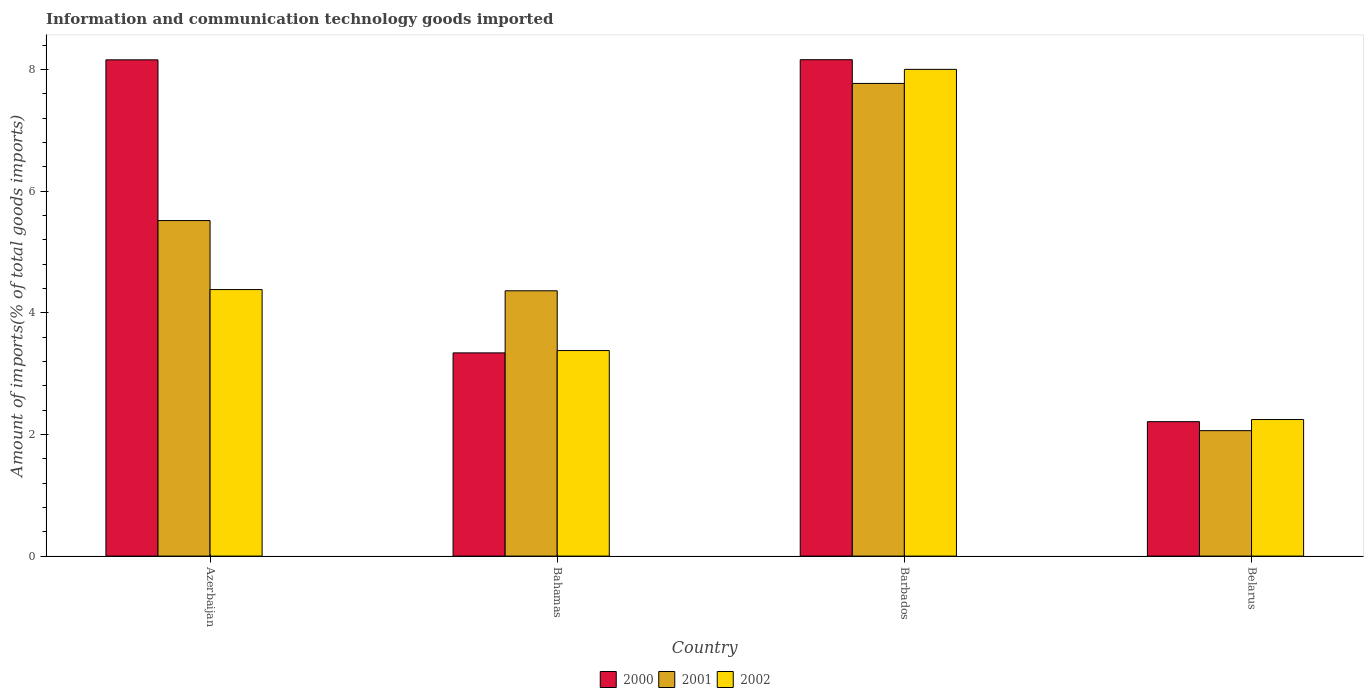Are the number of bars per tick equal to the number of legend labels?
Give a very brief answer. Yes. Are the number of bars on each tick of the X-axis equal?
Your answer should be compact. Yes. How many bars are there on the 3rd tick from the right?
Your answer should be compact. 3. What is the label of the 3rd group of bars from the left?
Ensure brevity in your answer.  Barbados. What is the amount of goods imported in 2000 in Bahamas?
Your answer should be very brief. 3.34. Across all countries, what is the maximum amount of goods imported in 2001?
Your response must be concise. 7.77. Across all countries, what is the minimum amount of goods imported in 2001?
Give a very brief answer. 2.06. In which country was the amount of goods imported in 2002 maximum?
Make the answer very short. Barbados. In which country was the amount of goods imported in 2001 minimum?
Offer a terse response. Belarus. What is the total amount of goods imported in 2000 in the graph?
Ensure brevity in your answer.  21.88. What is the difference between the amount of goods imported in 2002 in Bahamas and that in Barbados?
Offer a very short reply. -4.62. What is the difference between the amount of goods imported in 2000 in Barbados and the amount of goods imported in 2001 in Belarus?
Offer a very short reply. 6.1. What is the average amount of goods imported in 2000 per country?
Offer a terse response. 5.47. What is the difference between the amount of goods imported of/in 2001 and amount of goods imported of/in 2000 in Barbados?
Your answer should be very brief. -0.39. In how many countries, is the amount of goods imported in 2002 greater than 6.4 %?
Offer a very short reply. 1. What is the ratio of the amount of goods imported in 2002 in Azerbaijan to that in Barbados?
Offer a terse response. 0.55. Is the difference between the amount of goods imported in 2001 in Azerbaijan and Bahamas greater than the difference between the amount of goods imported in 2000 in Azerbaijan and Bahamas?
Provide a short and direct response. No. What is the difference between the highest and the second highest amount of goods imported in 2002?
Provide a short and direct response. 4.62. What is the difference between the highest and the lowest amount of goods imported in 2000?
Make the answer very short. 5.95. In how many countries, is the amount of goods imported in 2002 greater than the average amount of goods imported in 2002 taken over all countries?
Your response must be concise. 1. Is the sum of the amount of goods imported in 2002 in Azerbaijan and Bahamas greater than the maximum amount of goods imported in 2001 across all countries?
Your answer should be very brief. No. What does the 1st bar from the left in Belarus represents?
Your answer should be compact. 2000. Is it the case that in every country, the sum of the amount of goods imported in 2000 and amount of goods imported in 2001 is greater than the amount of goods imported in 2002?
Ensure brevity in your answer.  Yes. What is the difference between two consecutive major ticks on the Y-axis?
Keep it short and to the point. 2. Does the graph contain grids?
Offer a terse response. No. Where does the legend appear in the graph?
Your response must be concise. Bottom center. How many legend labels are there?
Provide a short and direct response. 3. How are the legend labels stacked?
Make the answer very short. Horizontal. What is the title of the graph?
Provide a short and direct response. Information and communication technology goods imported. Does "1997" appear as one of the legend labels in the graph?
Keep it short and to the point. No. What is the label or title of the Y-axis?
Make the answer very short. Amount of imports(% of total goods imports). What is the Amount of imports(% of total goods imports) of 2000 in Azerbaijan?
Provide a short and direct response. 8.16. What is the Amount of imports(% of total goods imports) of 2001 in Azerbaijan?
Ensure brevity in your answer.  5.52. What is the Amount of imports(% of total goods imports) in 2002 in Azerbaijan?
Ensure brevity in your answer.  4.38. What is the Amount of imports(% of total goods imports) of 2000 in Bahamas?
Your response must be concise. 3.34. What is the Amount of imports(% of total goods imports) in 2001 in Bahamas?
Give a very brief answer. 4.36. What is the Amount of imports(% of total goods imports) of 2002 in Bahamas?
Your answer should be very brief. 3.38. What is the Amount of imports(% of total goods imports) in 2000 in Barbados?
Provide a succinct answer. 8.16. What is the Amount of imports(% of total goods imports) of 2001 in Barbados?
Make the answer very short. 7.77. What is the Amount of imports(% of total goods imports) in 2002 in Barbados?
Offer a terse response. 8. What is the Amount of imports(% of total goods imports) in 2000 in Belarus?
Ensure brevity in your answer.  2.21. What is the Amount of imports(% of total goods imports) in 2001 in Belarus?
Provide a short and direct response. 2.06. What is the Amount of imports(% of total goods imports) in 2002 in Belarus?
Your answer should be very brief. 2.25. Across all countries, what is the maximum Amount of imports(% of total goods imports) in 2000?
Ensure brevity in your answer.  8.16. Across all countries, what is the maximum Amount of imports(% of total goods imports) of 2001?
Provide a short and direct response. 7.77. Across all countries, what is the maximum Amount of imports(% of total goods imports) in 2002?
Keep it short and to the point. 8. Across all countries, what is the minimum Amount of imports(% of total goods imports) of 2000?
Give a very brief answer. 2.21. Across all countries, what is the minimum Amount of imports(% of total goods imports) of 2001?
Your answer should be compact. 2.06. Across all countries, what is the minimum Amount of imports(% of total goods imports) in 2002?
Offer a very short reply. 2.25. What is the total Amount of imports(% of total goods imports) in 2000 in the graph?
Make the answer very short. 21.88. What is the total Amount of imports(% of total goods imports) in 2001 in the graph?
Offer a terse response. 19.71. What is the total Amount of imports(% of total goods imports) in 2002 in the graph?
Your response must be concise. 18.01. What is the difference between the Amount of imports(% of total goods imports) in 2000 in Azerbaijan and that in Bahamas?
Make the answer very short. 4.82. What is the difference between the Amount of imports(% of total goods imports) in 2001 in Azerbaijan and that in Bahamas?
Ensure brevity in your answer.  1.15. What is the difference between the Amount of imports(% of total goods imports) in 2002 in Azerbaijan and that in Bahamas?
Provide a short and direct response. 1. What is the difference between the Amount of imports(% of total goods imports) of 2000 in Azerbaijan and that in Barbados?
Your answer should be compact. -0. What is the difference between the Amount of imports(% of total goods imports) in 2001 in Azerbaijan and that in Barbados?
Your answer should be very brief. -2.26. What is the difference between the Amount of imports(% of total goods imports) of 2002 in Azerbaijan and that in Barbados?
Your answer should be compact. -3.62. What is the difference between the Amount of imports(% of total goods imports) in 2000 in Azerbaijan and that in Belarus?
Ensure brevity in your answer.  5.95. What is the difference between the Amount of imports(% of total goods imports) in 2001 in Azerbaijan and that in Belarus?
Provide a succinct answer. 3.45. What is the difference between the Amount of imports(% of total goods imports) of 2002 in Azerbaijan and that in Belarus?
Make the answer very short. 2.14. What is the difference between the Amount of imports(% of total goods imports) of 2000 in Bahamas and that in Barbados?
Provide a succinct answer. -4.82. What is the difference between the Amount of imports(% of total goods imports) in 2001 in Bahamas and that in Barbados?
Provide a succinct answer. -3.41. What is the difference between the Amount of imports(% of total goods imports) of 2002 in Bahamas and that in Barbados?
Offer a terse response. -4.62. What is the difference between the Amount of imports(% of total goods imports) of 2000 in Bahamas and that in Belarus?
Your answer should be very brief. 1.13. What is the difference between the Amount of imports(% of total goods imports) of 2001 in Bahamas and that in Belarus?
Provide a short and direct response. 2.3. What is the difference between the Amount of imports(% of total goods imports) of 2002 in Bahamas and that in Belarus?
Make the answer very short. 1.13. What is the difference between the Amount of imports(% of total goods imports) in 2000 in Barbados and that in Belarus?
Make the answer very short. 5.95. What is the difference between the Amount of imports(% of total goods imports) of 2001 in Barbados and that in Belarus?
Provide a succinct answer. 5.71. What is the difference between the Amount of imports(% of total goods imports) in 2002 in Barbados and that in Belarus?
Offer a very short reply. 5.76. What is the difference between the Amount of imports(% of total goods imports) of 2000 in Azerbaijan and the Amount of imports(% of total goods imports) of 2001 in Bahamas?
Offer a terse response. 3.8. What is the difference between the Amount of imports(% of total goods imports) of 2000 in Azerbaijan and the Amount of imports(% of total goods imports) of 2002 in Bahamas?
Provide a short and direct response. 4.78. What is the difference between the Amount of imports(% of total goods imports) of 2001 in Azerbaijan and the Amount of imports(% of total goods imports) of 2002 in Bahamas?
Offer a terse response. 2.14. What is the difference between the Amount of imports(% of total goods imports) of 2000 in Azerbaijan and the Amount of imports(% of total goods imports) of 2001 in Barbados?
Ensure brevity in your answer.  0.39. What is the difference between the Amount of imports(% of total goods imports) of 2000 in Azerbaijan and the Amount of imports(% of total goods imports) of 2002 in Barbados?
Offer a very short reply. 0.16. What is the difference between the Amount of imports(% of total goods imports) in 2001 in Azerbaijan and the Amount of imports(% of total goods imports) in 2002 in Barbados?
Your answer should be compact. -2.49. What is the difference between the Amount of imports(% of total goods imports) of 2000 in Azerbaijan and the Amount of imports(% of total goods imports) of 2001 in Belarus?
Offer a very short reply. 6.1. What is the difference between the Amount of imports(% of total goods imports) of 2000 in Azerbaijan and the Amount of imports(% of total goods imports) of 2002 in Belarus?
Offer a terse response. 5.92. What is the difference between the Amount of imports(% of total goods imports) of 2001 in Azerbaijan and the Amount of imports(% of total goods imports) of 2002 in Belarus?
Your answer should be compact. 3.27. What is the difference between the Amount of imports(% of total goods imports) of 2000 in Bahamas and the Amount of imports(% of total goods imports) of 2001 in Barbados?
Ensure brevity in your answer.  -4.43. What is the difference between the Amount of imports(% of total goods imports) in 2000 in Bahamas and the Amount of imports(% of total goods imports) in 2002 in Barbados?
Ensure brevity in your answer.  -4.66. What is the difference between the Amount of imports(% of total goods imports) in 2001 in Bahamas and the Amount of imports(% of total goods imports) in 2002 in Barbados?
Your answer should be very brief. -3.64. What is the difference between the Amount of imports(% of total goods imports) in 2000 in Bahamas and the Amount of imports(% of total goods imports) in 2001 in Belarus?
Provide a short and direct response. 1.28. What is the difference between the Amount of imports(% of total goods imports) in 2000 in Bahamas and the Amount of imports(% of total goods imports) in 2002 in Belarus?
Keep it short and to the point. 1.1. What is the difference between the Amount of imports(% of total goods imports) of 2001 in Bahamas and the Amount of imports(% of total goods imports) of 2002 in Belarus?
Your answer should be very brief. 2.12. What is the difference between the Amount of imports(% of total goods imports) of 2000 in Barbados and the Amount of imports(% of total goods imports) of 2001 in Belarus?
Your answer should be compact. 6.1. What is the difference between the Amount of imports(% of total goods imports) in 2000 in Barbados and the Amount of imports(% of total goods imports) in 2002 in Belarus?
Provide a short and direct response. 5.92. What is the difference between the Amount of imports(% of total goods imports) in 2001 in Barbados and the Amount of imports(% of total goods imports) in 2002 in Belarus?
Provide a short and direct response. 5.53. What is the average Amount of imports(% of total goods imports) in 2000 per country?
Make the answer very short. 5.47. What is the average Amount of imports(% of total goods imports) of 2001 per country?
Keep it short and to the point. 4.93. What is the average Amount of imports(% of total goods imports) in 2002 per country?
Offer a very short reply. 4.5. What is the difference between the Amount of imports(% of total goods imports) in 2000 and Amount of imports(% of total goods imports) in 2001 in Azerbaijan?
Your response must be concise. 2.64. What is the difference between the Amount of imports(% of total goods imports) in 2000 and Amount of imports(% of total goods imports) in 2002 in Azerbaijan?
Keep it short and to the point. 3.78. What is the difference between the Amount of imports(% of total goods imports) of 2001 and Amount of imports(% of total goods imports) of 2002 in Azerbaijan?
Offer a terse response. 1.13. What is the difference between the Amount of imports(% of total goods imports) in 2000 and Amount of imports(% of total goods imports) in 2001 in Bahamas?
Your answer should be compact. -1.02. What is the difference between the Amount of imports(% of total goods imports) in 2000 and Amount of imports(% of total goods imports) in 2002 in Bahamas?
Give a very brief answer. -0.04. What is the difference between the Amount of imports(% of total goods imports) of 2001 and Amount of imports(% of total goods imports) of 2002 in Bahamas?
Offer a terse response. 0.98. What is the difference between the Amount of imports(% of total goods imports) in 2000 and Amount of imports(% of total goods imports) in 2001 in Barbados?
Your response must be concise. 0.39. What is the difference between the Amount of imports(% of total goods imports) of 2000 and Amount of imports(% of total goods imports) of 2002 in Barbados?
Your response must be concise. 0.16. What is the difference between the Amount of imports(% of total goods imports) in 2001 and Amount of imports(% of total goods imports) in 2002 in Barbados?
Provide a short and direct response. -0.23. What is the difference between the Amount of imports(% of total goods imports) in 2000 and Amount of imports(% of total goods imports) in 2001 in Belarus?
Provide a short and direct response. 0.15. What is the difference between the Amount of imports(% of total goods imports) of 2000 and Amount of imports(% of total goods imports) of 2002 in Belarus?
Your response must be concise. -0.03. What is the difference between the Amount of imports(% of total goods imports) in 2001 and Amount of imports(% of total goods imports) in 2002 in Belarus?
Ensure brevity in your answer.  -0.18. What is the ratio of the Amount of imports(% of total goods imports) in 2000 in Azerbaijan to that in Bahamas?
Your answer should be compact. 2.44. What is the ratio of the Amount of imports(% of total goods imports) of 2001 in Azerbaijan to that in Bahamas?
Ensure brevity in your answer.  1.26. What is the ratio of the Amount of imports(% of total goods imports) of 2002 in Azerbaijan to that in Bahamas?
Provide a short and direct response. 1.3. What is the ratio of the Amount of imports(% of total goods imports) of 2001 in Azerbaijan to that in Barbados?
Offer a very short reply. 0.71. What is the ratio of the Amount of imports(% of total goods imports) of 2002 in Azerbaijan to that in Barbados?
Provide a succinct answer. 0.55. What is the ratio of the Amount of imports(% of total goods imports) of 2000 in Azerbaijan to that in Belarus?
Provide a succinct answer. 3.69. What is the ratio of the Amount of imports(% of total goods imports) in 2001 in Azerbaijan to that in Belarus?
Give a very brief answer. 2.67. What is the ratio of the Amount of imports(% of total goods imports) in 2002 in Azerbaijan to that in Belarus?
Your response must be concise. 1.95. What is the ratio of the Amount of imports(% of total goods imports) of 2000 in Bahamas to that in Barbados?
Provide a succinct answer. 0.41. What is the ratio of the Amount of imports(% of total goods imports) of 2001 in Bahamas to that in Barbados?
Provide a succinct answer. 0.56. What is the ratio of the Amount of imports(% of total goods imports) of 2002 in Bahamas to that in Barbados?
Offer a terse response. 0.42. What is the ratio of the Amount of imports(% of total goods imports) in 2000 in Bahamas to that in Belarus?
Offer a terse response. 1.51. What is the ratio of the Amount of imports(% of total goods imports) in 2001 in Bahamas to that in Belarus?
Make the answer very short. 2.12. What is the ratio of the Amount of imports(% of total goods imports) of 2002 in Bahamas to that in Belarus?
Provide a succinct answer. 1.51. What is the ratio of the Amount of imports(% of total goods imports) in 2000 in Barbados to that in Belarus?
Give a very brief answer. 3.69. What is the ratio of the Amount of imports(% of total goods imports) of 2001 in Barbados to that in Belarus?
Keep it short and to the point. 3.77. What is the ratio of the Amount of imports(% of total goods imports) in 2002 in Barbados to that in Belarus?
Provide a short and direct response. 3.56. What is the difference between the highest and the second highest Amount of imports(% of total goods imports) in 2000?
Offer a very short reply. 0. What is the difference between the highest and the second highest Amount of imports(% of total goods imports) of 2001?
Make the answer very short. 2.26. What is the difference between the highest and the second highest Amount of imports(% of total goods imports) in 2002?
Offer a very short reply. 3.62. What is the difference between the highest and the lowest Amount of imports(% of total goods imports) in 2000?
Your response must be concise. 5.95. What is the difference between the highest and the lowest Amount of imports(% of total goods imports) in 2001?
Make the answer very short. 5.71. What is the difference between the highest and the lowest Amount of imports(% of total goods imports) of 2002?
Offer a terse response. 5.76. 